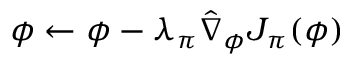Convert formula to latex. <formula><loc_0><loc_0><loc_500><loc_500>\phi \leftarrow \phi - { \lambda _ { \pi } } { \hat { \nabla } _ { \phi } } { J _ { \pi } } ( \phi )</formula> 